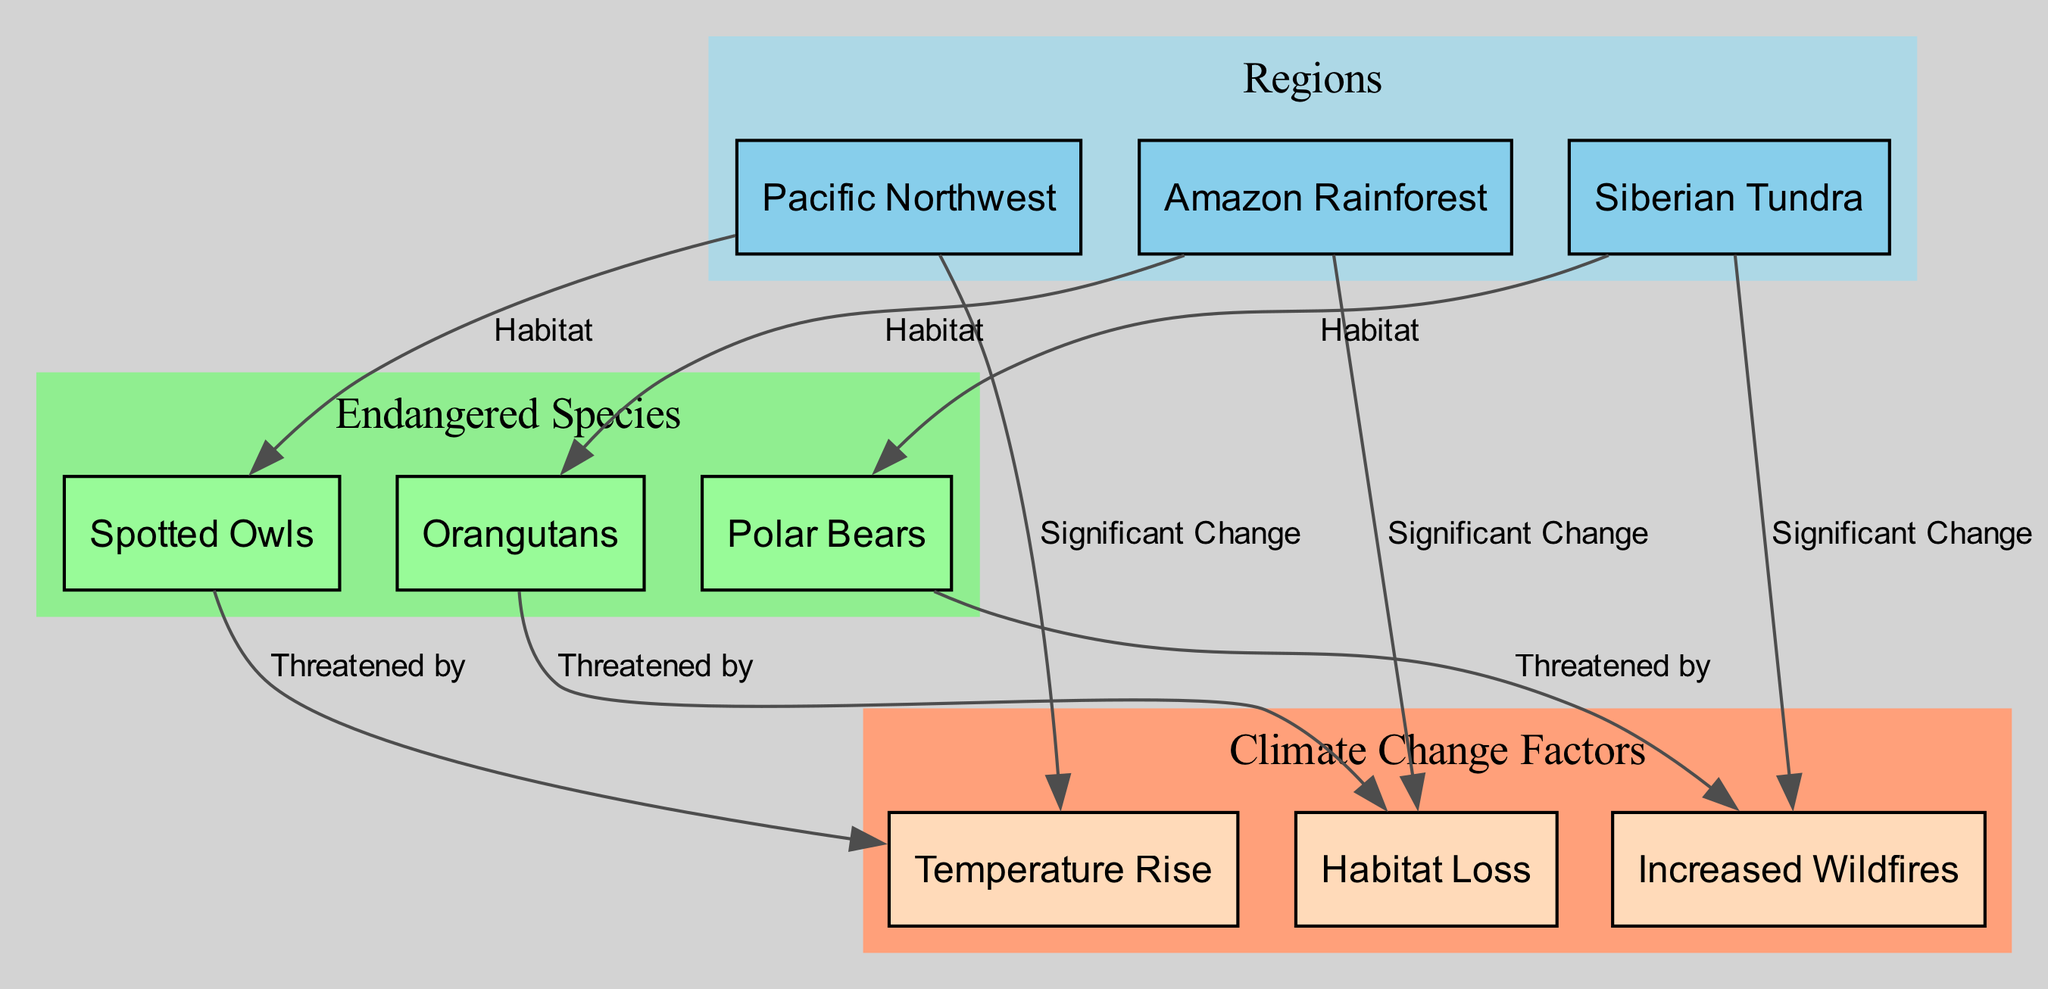What region is home to the Spotted Owls? The Spotted Owls are located in the Pacific Northwest, as indicated by the edge connecting the species node to the region node showing their habitat.
Answer: Pacific Northwest Which species is threatened by increased wildfires? The diagram shows that Polar Bears are specifically threatened by increased wildfires, as indicated by the edge labeled "Threatened by" connecting the Polar Bears node to the Increased Wildfires node.
Answer: Polar Bears How many regions are represented in the diagram? By counting the nodes categorized as regions, we find that there are three unique region nodes: Pacific Northwest, Amazon Rainforest, and Siberian Tundra.
Answer: 3 What climate change factor is significant in the Amazon Rainforest? The diagram states that habitat loss is the significant climate change factor affecting the Amazon Rainforest, as indicated by the edge connecting the Amazon Rainforest node to the Habitat Loss node.
Answer: Habitat Loss Which species and climate change factor are linked in the Pacific Northwest? The diagram connects Spotted Owls to the climate change factor of temperature rise, indicated by the edge labeled "Threatened by." This establishes a direct link between the species and the climate factor.
Answer: Temperature Rise How many climate change factors threaten Orangutans? From the diagram, we see that Orangutans are directly threatened by habitat loss, which is the only climate change factor mentioned in connection with them, as represented by the corresponding edge.
Answer: 1 Which region is primarily affected by significant temperature rise? The diagram shows that the Pacific Northwest is the region primarily affected by significant temperature rise, as depicted by the edge labeled "Significant Change" pointing from Pacific Northwest to Temperature Rise.
Answer: Pacific Northwest What type of habitat does the Siberian Tundra provide? The Siberian Tundra provides a habitat for Polar Bears, as directly indicated by the edge labeled "Habitat" linking the Siberian Tundra node to the Polar Bears node.
Answer: Habitat Which endangered species are found in the Amazon Rainforest? According to the diagram, Orangutans find their habitat in the Amazon Rainforest, as indicated by the direct edge connecting them.
Answer: Orangutans 